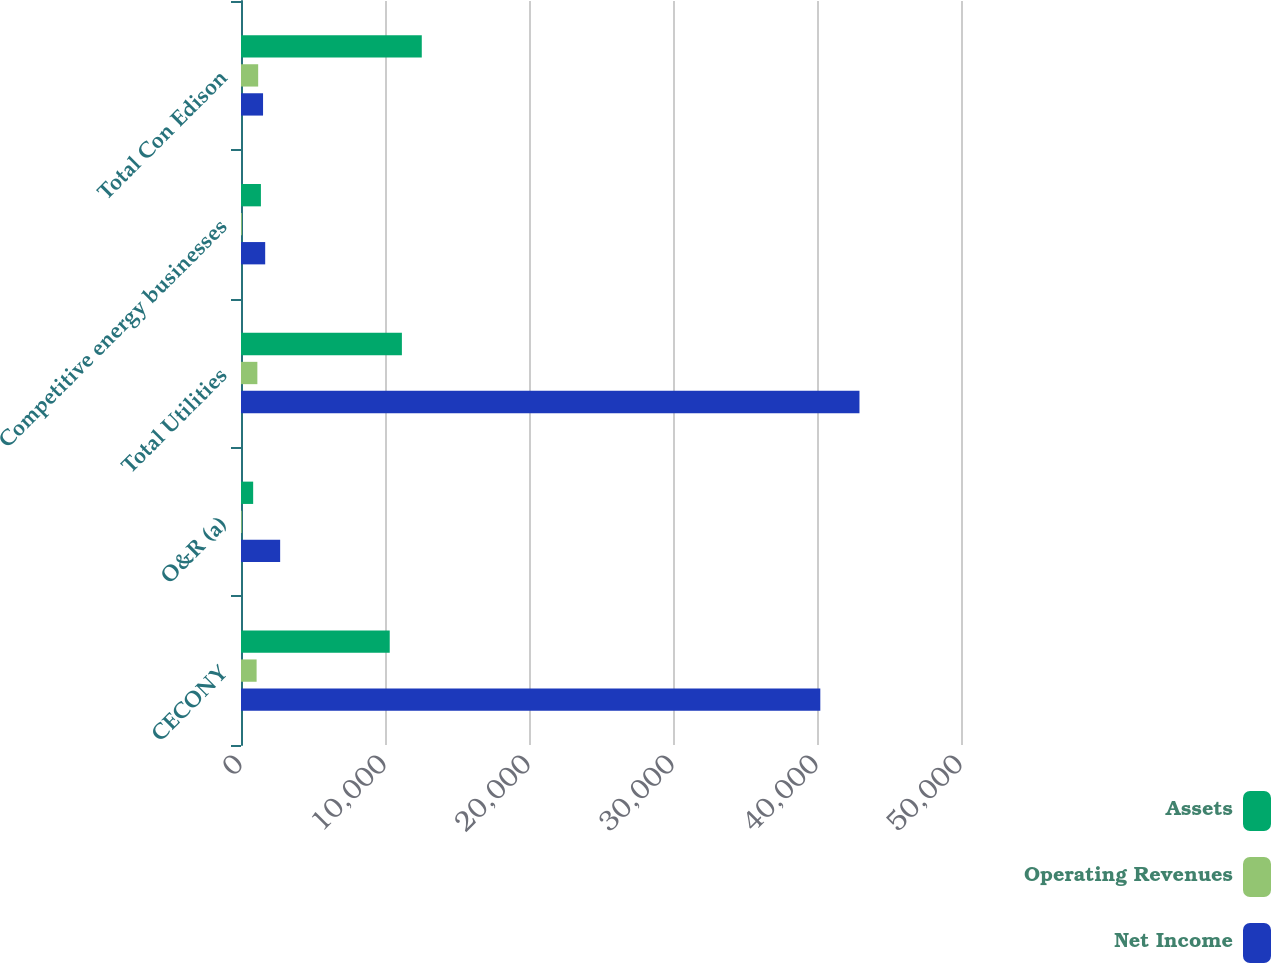Convert chart to OTSL. <chart><loc_0><loc_0><loc_500><loc_500><stacked_bar_chart><ecel><fcel>CECONY<fcel>O&R (a)<fcel>Total Utilities<fcel>Competitive energy businesses<fcel>Total Con Edison<nl><fcel>Assets<fcel>10328<fcel>845<fcel>11173<fcel>1383<fcel>12554<nl><fcel>Operating Revenues<fcel>1084<fcel>52<fcel>1136<fcel>59<fcel>1193<nl><fcel>Net Income<fcel>40230<fcel>2719<fcel>42949<fcel>1680<fcel>1531.5<nl></chart> 